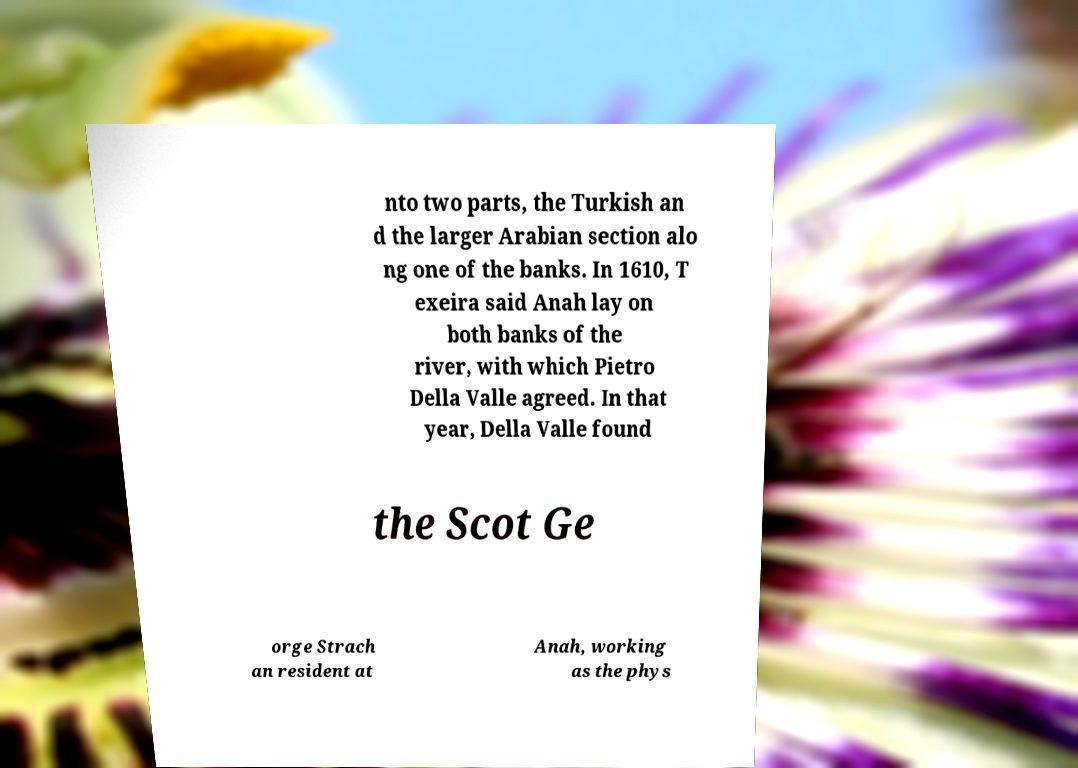What messages or text are displayed in this image? I need them in a readable, typed format. nto two parts, the Turkish an d the larger Arabian section alo ng one of the banks. In 1610, T exeira said Anah lay on both banks of the river, with which Pietro Della Valle agreed. In that year, Della Valle found the Scot Ge orge Strach an resident at Anah, working as the phys 